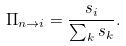Convert formula to latex. <formula><loc_0><loc_0><loc_500><loc_500>\Pi _ { n \rightarrow i } = \frac { s _ { i } } { \sum _ { k } s _ { k } } .</formula> 